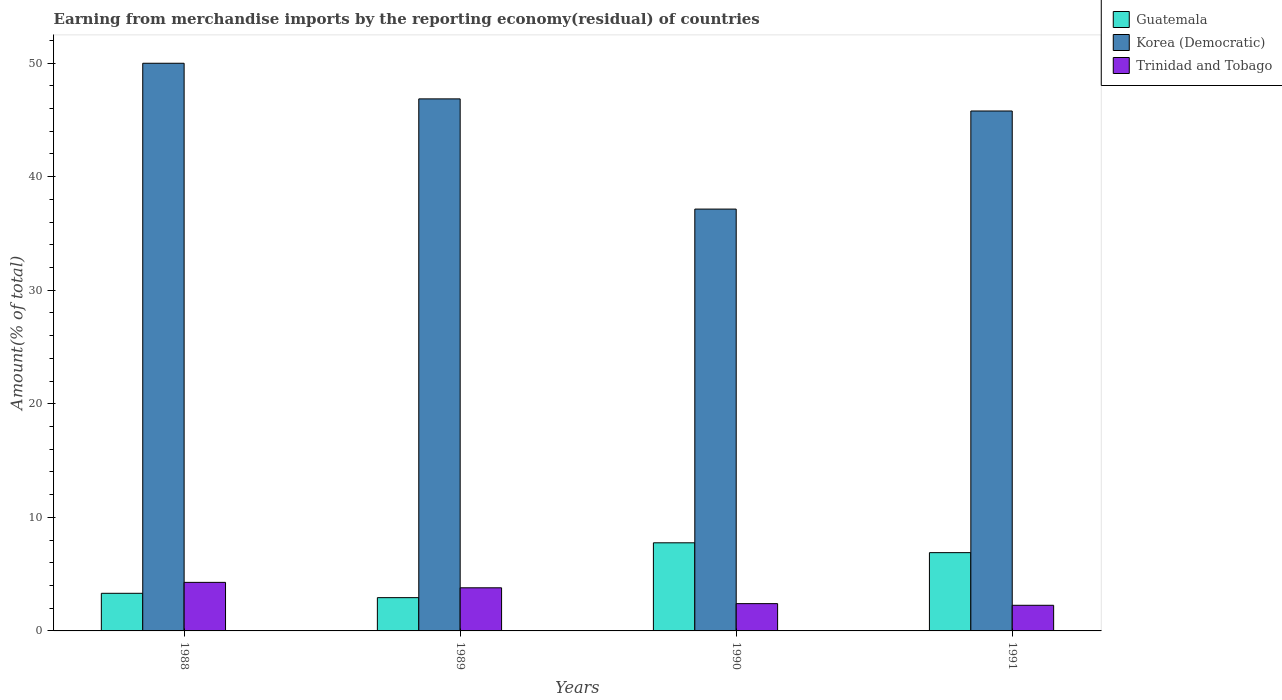How many different coloured bars are there?
Your answer should be very brief. 3. How many groups of bars are there?
Keep it short and to the point. 4. How many bars are there on the 2nd tick from the left?
Offer a terse response. 3. How many bars are there on the 2nd tick from the right?
Your answer should be compact. 3. What is the percentage of amount earned from merchandise imports in Guatemala in 1991?
Provide a succinct answer. 6.89. Across all years, what is the maximum percentage of amount earned from merchandise imports in Korea (Democratic)?
Offer a terse response. 49.98. Across all years, what is the minimum percentage of amount earned from merchandise imports in Trinidad and Tobago?
Your answer should be very brief. 2.26. What is the total percentage of amount earned from merchandise imports in Trinidad and Tobago in the graph?
Your answer should be compact. 12.73. What is the difference between the percentage of amount earned from merchandise imports in Korea (Democratic) in 1988 and that in 1990?
Make the answer very short. 12.84. What is the difference between the percentage of amount earned from merchandise imports in Korea (Democratic) in 1989 and the percentage of amount earned from merchandise imports in Trinidad and Tobago in 1991?
Give a very brief answer. 44.59. What is the average percentage of amount earned from merchandise imports in Trinidad and Tobago per year?
Your answer should be very brief. 3.18. In the year 1991, what is the difference between the percentage of amount earned from merchandise imports in Korea (Democratic) and percentage of amount earned from merchandise imports in Guatemala?
Your answer should be compact. 38.89. In how many years, is the percentage of amount earned from merchandise imports in Korea (Democratic) greater than 36 %?
Give a very brief answer. 4. What is the ratio of the percentage of amount earned from merchandise imports in Korea (Democratic) in 1989 to that in 1991?
Your response must be concise. 1.02. Is the percentage of amount earned from merchandise imports in Trinidad and Tobago in 1990 less than that in 1991?
Provide a succinct answer. No. Is the difference between the percentage of amount earned from merchandise imports in Korea (Democratic) in 1990 and 1991 greater than the difference between the percentage of amount earned from merchandise imports in Guatemala in 1990 and 1991?
Make the answer very short. No. What is the difference between the highest and the second highest percentage of amount earned from merchandise imports in Guatemala?
Offer a terse response. 0.87. What is the difference between the highest and the lowest percentage of amount earned from merchandise imports in Korea (Democratic)?
Your answer should be compact. 12.84. What does the 2nd bar from the left in 1990 represents?
Your answer should be very brief. Korea (Democratic). What does the 3rd bar from the right in 1988 represents?
Offer a terse response. Guatemala. How many bars are there?
Your answer should be very brief. 12. Are all the bars in the graph horizontal?
Make the answer very short. No. Are the values on the major ticks of Y-axis written in scientific E-notation?
Provide a succinct answer. No. Does the graph contain grids?
Ensure brevity in your answer.  No. How many legend labels are there?
Your answer should be compact. 3. What is the title of the graph?
Provide a succinct answer. Earning from merchandise imports by the reporting economy(residual) of countries. Does "Brunei Darussalam" appear as one of the legend labels in the graph?
Ensure brevity in your answer.  No. What is the label or title of the X-axis?
Ensure brevity in your answer.  Years. What is the label or title of the Y-axis?
Provide a succinct answer. Amount(% of total). What is the Amount(% of total) of Guatemala in 1988?
Your answer should be very brief. 3.31. What is the Amount(% of total) of Korea (Democratic) in 1988?
Your answer should be very brief. 49.98. What is the Amount(% of total) in Trinidad and Tobago in 1988?
Keep it short and to the point. 4.28. What is the Amount(% of total) in Guatemala in 1989?
Your answer should be very brief. 2.93. What is the Amount(% of total) in Korea (Democratic) in 1989?
Your answer should be compact. 46.85. What is the Amount(% of total) of Trinidad and Tobago in 1989?
Provide a succinct answer. 3.8. What is the Amount(% of total) of Guatemala in 1990?
Make the answer very short. 7.76. What is the Amount(% of total) in Korea (Democratic) in 1990?
Provide a short and direct response. 37.14. What is the Amount(% of total) of Trinidad and Tobago in 1990?
Ensure brevity in your answer.  2.4. What is the Amount(% of total) of Guatemala in 1991?
Make the answer very short. 6.89. What is the Amount(% of total) in Korea (Democratic) in 1991?
Ensure brevity in your answer.  45.78. What is the Amount(% of total) of Trinidad and Tobago in 1991?
Make the answer very short. 2.26. Across all years, what is the maximum Amount(% of total) in Guatemala?
Provide a short and direct response. 7.76. Across all years, what is the maximum Amount(% of total) of Korea (Democratic)?
Your answer should be compact. 49.98. Across all years, what is the maximum Amount(% of total) of Trinidad and Tobago?
Make the answer very short. 4.28. Across all years, what is the minimum Amount(% of total) in Guatemala?
Offer a terse response. 2.93. Across all years, what is the minimum Amount(% of total) in Korea (Democratic)?
Keep it short and to the point. 37.14. Across all years, what is the minimum Amount(% of total) of Trinidad and Tobago?
Keep it short and to the point. 2.26. What is the total Amount(% of total) of Guatemala in the graph?
Give a very brief answer. 20.89. What is the total Amount(% of total) of Korea (Democratic) in the graph?
Keep it short and to the point. 179.75. What is the total Amount(% of total) in Trinidad and Tobago in the graph?
Offer a very short reply. 12.73. What is the difference between the Amount(% of total) in Guatemala in 1988 and that in 1989?
Keep it short and to the point. 0.38. What is the difference between the Amount(% of total) in Korea (Democratic) in 1988 and that in 1989?
Give a very brief answer. 3.14. What is the difference between the Amount(% of total) in Trinidad and Tobago in 1988 and that in 1989?
Keep it short and to the point. 0.48. What is the difference between the Amount(% of total) of Guatemala in 1988 and that in 1990?
Your answer should be very brief. -4.45. What is the difference between the Amount(% of total) of Korea (Democratic) in 1988 and that in 1990?
Ensure brevity in your answer.  12.84. What is the difference between the Amount(% of total) in Trinidad and Tobago in 1988 and that in 1990?
Offer a terse response. 1.87. What is the difference between the Amount(% of total) of Guatemala in 1988 and that in 1991?
Offer a very short reply. -3.58. What is the difference between the Amount(% of total) in Korea (Democratic) in 1988 and that in 1991?
Provide a short and direct response. 4.2. What is the difference between the Amount(% of total) in Trinidad and Tobago in 1988 and that in 1991?
Ensure brevity in your answer.  2.02. What is the difference between the Amount(% of total) of Guatemala in 1989 and that in 1990?
Keep it short and to the point. -4.83. What is the difference between the Amount(% of total) of Korea (Democratic) in 1989 and that in 1990?
Your response must be concise. 9.7. What is the difference between the Amount(% of total) in Trinidad and Tobago in 1989 and that in 1990?
Your response must be concise. 1.39. What is the difference between the Amount(% of total) of Guatemala in 1989 and that in 1991?
Provide a succinct answer. -3.96. What is the difference between the Amount(% of total) of Korea (Democratic) in 1989 and that in 1991?
Make the answer very short. 1.07. What is the difference between the Amount(% of total) in Trinidad and Tobago in 1989 and that in 1991?
Keep it short and to the point. 1.54. What is the difference between the Amount(% of total) of Guatemala in 1990 and that in 1991?
Provide a short and direct response. 0.87. What is the difference between the Amount(% of total) of Korea (Democratic) in 1990 and that in 1991?
Provide a short and direct response. -8.64. What is the difference between the Amount(% of total) of Trinidad and Tobago in 1990 and that in 1991?
Give a very brief answer. 0.15. What is the difference between the Amount(% of total) in Guatemala in 1988 and the Amount(% of total) in Korea (Democratic) in 1989?
Keep it short and to the point. -43.53. What is the difference between the Amount(% of total) of Guatemala in 1988 and the Amount(% of total) of Trinidad and Tobago in 1989?
Your answer should be compact. -0.48. What is the difference between the Amount(% of total) in Korea (Democratic) in 1988 and the Amount(% of total) in Trinidad and Tobago in 1989?
Offer a terse response. 46.19. What is the difference between the Amount(% of total) of Guatemala in 1988 and the Amount(% of total) of Korea (Democratic) in 1990?
Keep it short and to the point. -33.83. What is the difference between the Amount(% of total) in Korea (Democratic) in 1988 and the Amount(% of total) in Trinidad and Tobago in 1990?
Offer a terse response. 47.58. What is the difference between the Amount(% of total) of Guatemala in 1988 and the Amount(% of total) of Korea (Democratic) in 1991?
Your answer should be compact. -42.47. What is the difference between the Amount(% of total) of Guatemala in 1988 and the Amount(% of total) of Trinidad and Tobago in 1991?
Provide a succinct answer. 1.06. What is the difference between the Amount(% of total) in Korea (Democratic) in 1988 and the Amount(% of total) in Trinidad and Tobago in 1991?
Keep it short and to the point. 47.73. What is the difference between the Amount(% of total) in Guatemala in 1989 and the Amount(% of total) in Korea (Democratic) in 1990?
Keep it short and to the point. -34.21. What is the difference between the Amount(% of total) of Guatemala in 1989 and the Amount(% of total) of Trinidad and Tobago in 1990?
Ensure brevity in your answer.  0.53. What is the difference between the Amount(% of total) of Korea (Democratic) in 1989 and the Amount(% of total) of Trinidad and Tobago in 1990?
Offer a very short reply. 44.44. What is the difference between the Amount(% of total) in Guatemala in 1989 and the Amount(% of total) in Korea (Democratic) in 1991?
Your answer should be compact. -42.85. What is the difference between the Amount(% of total) in Guatemala in 1989 and the Amount(% of total) in Trinidad and Tobago in 1991?
Make the answer very short. 0.67. What is the difference between the Amount(% of total) of Korea (Democratic) in 1989 and the Amount(% of total) of Trinidad and Tobago in 1991?
Keep it short and to the point. 44.59. What is the difference between the Amount(% of total) in Guatemala in 1990 and the Amount(% of total) in Korea (Democratic) in 1991?
Provide a succinct answer. -38.02. What is the difference between the Amount(% of total) in Guatemala in 1990 and the Amount(% of total) in Trinidad and Tobago in 1991?
Make the answer very short. 5.5. What is the difference between the Amount(% of total) in Korea (Democratic) in 1990 and the Amount(% of total) in Trinidad and Tobago in 1991?
Provide a succinct answer. 34.89. What is the average Amount(% of total) of Guatemala per year?
Ensure brevity in your answer.  5.22. What is the average Amount(% of total) in Korea (Democratic) per year?
Make the answer very short. 44.94. What is the average Amount(% of total) of Trinidad and Tobago per year?
Make the answer very short. 3.18. In the year 1988, what is the difference between the Amount(% of total) of Guatemala and Amount(% of total) of Korea (Democratic)?
Give a very brief answer. -46.67. In the year 1988, what is the difference between the Amount(% of total) in Guatemala and Amount(% of total) in Trinidad and Tobago?
Your answer should be very brief. -0.96. In the year 1988, what is the difference between the Amount(% of total) in Korea (Democratic) and Amount(% of total) in Trinidad and Tobago?
Keep it short and to the point. 45.71. In the year 1989, what is the difference between the Amount(% of total) of Guatemala and Amount(% of total) of Korea (Democratic)?
Give a very brief answer. -43.92. In the year 1989, what is the difference between the Amount(% of total) of Guatemala and Amount(% of total) of Trinidad and Tobago?
Keep it short and to the point. -0.87. In the year 1989, what is the difference between the Amount(% of total) of Korea (Democratic) and Amount(% of total) of Trinidad and Tobago?
Keep it short and to the point. 43.05. In the year 1990, what is the difference between the Amount(% of total) of Guatemala and Amount(% of total) of Korea (Democratic)?
Your answer should be very brief. -29.38. In the year 1990, what is the difference between the Amount(% of total) in Guatemala and Amount(% of total) in Trinidad and Tobago?
Offer a very short reply. 5.36. In the year 1990, what is the difference between the Amount(% of total) of Korea (Democratic) and Amount(% of total) of Trinidad and Tobago?
Ensure brevity in your answer.  34.74. In the year 1991, what is the difference between the Amount(% of total) in Guatemala and Amount(% of total) in Korea (Democratic)?
Give a very brief answer. -38.89. In the year 1991, what is the difference between the Amount(% of total) of Guatemala and Amount(% of total) of Trinidad and Tobago?
Keep it short and to the point. 4.64. In the year 1991, what is the difference between the Amount(% of total) in Korea (Democratic) and Amount(% of total) in Trinidad and Tobago?
Your response must be concise. 43.52. What is the ratio of the Amount(% of total) in Guatemala in 1988 to that in 1989?
Offer a terse response. 1.13. What is the ratio of the Amount(% of total) in Korea (Democratic) in 1988 to that in 1989?
Ensure brevity in your answer.  1.07. What is the ratio of the Amount(% of total) in Trinidad and Tobago in 1988 to that in 1989?
Your response must be concise. 1.13. What is the ratio of the Amount(% of total) of Guatemala in 1988 to that in 1990?
Your answer should be very brief. 0.43. What is the ratio of the Amount(% of total) in Korea (Democratic) in 1988 to that in 1990?
Your answer should be very brief. 1.35. What is the ratio of the Amount(% of total) in Trinidad and Tobago in 1988 to that in 1990?
Offer a terse response. 1.78. What is the ratio of the Amount(% of total) of Guatemala in 1988 to that in 1991?
Your answer should be compact. 0.48. What is the ratio of the Amount(% of total) in Korea (Democratic) in 1988 to that in 1991?
Offer a very short reply. 1.09. What is the ratio of the Amount(% of total) in Trinidad and Tobago in 1988 to that in 1991?
Provide a short and direct response. 1.9. What is the ratio of the Amount(% of total) in Guatemala in 1989 to that in 1990?
Your response must be concise. 0.38. What is the ratio of the Amount(% of total) of Korea (Democratic) in 1989 to that in 1990?
Offer a terse response. 1.26. What is the ratio of the Amount(% of total) in Trinidad and Tobago in 1989 to that in 1990?
Your answer should be very brief. 1.58. What is the ratio of the Amount(% of total) of Guatemala in 1989 to that in 1991?
Your answer should be very brief. 0.43. What is the ratio of the Amount(% of total) in Korea (Democratic) in 1989 to that in 1991?
Keep it short and to the point. 1.02. What is the ratio of the Amount(% of total) in Trinidad and Tobago in 1989 to that in 1991?
Give a very brief answer. 1.68. What is the ratio of the Amount(% of total) in Guatemala in 1990 to that in 1991?
Your response must be concise. 1.13. What is the ratio of the Amount(% of total) of Korea (Democratic) in 1990 to that in 1991?
Give a very brief answer. 0.81. What is the ratio of the Amount(% of total) of Trinidad and Tobago in 1990 to that in 1991?
Your response must be concise. 1.06. What is the difference between the highest and the second highest Amount(% of total) of Guatemala?
Provide a short and direct response. 0.87. What is the difference between the highest and the second highest Amount(% of total) in Korea (Democratic)?
Give a very brief answer. 3.14. What is the difference between the highest and the second highest Amount(% of total) of Trinidad and Tobago?
Your answer should be compact. 0.48. What is the difference between the highest and the lowest Amount(% of total) in Guatemala?
Offer a terse response. 4.83. What is the difference between the highest and the lowest Amount(% of total) of Korea (Democratic)?
Your answer should be very brief. 12.84. What is the difference between the highest and the lowest Amount(% of total) in Trinidad and Tobago?
Make the answer very short. 2.02. 